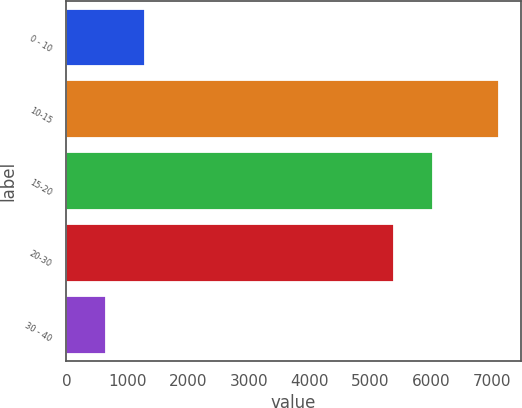Convert chart. <chart><loc_0><loc_0><loc_500><loc_500><bar_chart><fcel>0 - 10<fcel>10-15<fcel>15-20<fcel>20-30<fcel>30 - 40<nl><fcel>1290.5<fcel>7109<fcel>6025.5<fcel>5379<fcel>644<nl></chart> 